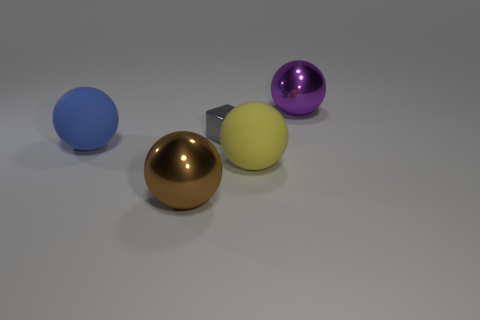How do the objects in the image relate to each other in terms of size? The objects vary in size and present an interesting comparison. The blue sphere is the largest object in view. The gold sphere is slightly smaller than the blue, and the purple sphere is the smallest among the spheres. The yellow cube is smaller in height compared to the spheres but has an edge length similar to the diameter of the purple sphere, making the objects intersect in size in an intriguing manner. 